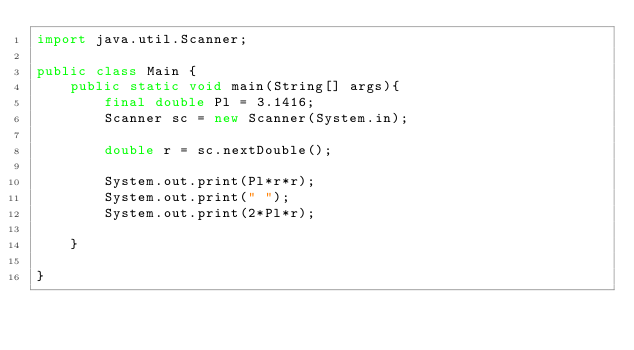Convert code to text. <code><loc_0><loc_0><loc_500><loc_500><_Java_>import java.util.Scanner;

public class Main {
	public static void main(String[] args){
		final double Pl = 3.1416;
		Scanner sc = new Scanner(System.in);

		double r = sc.nextDouble();
		
		System.out.print(Pl*r*r);
		System.out.print(" ");
		System.out.print(2*Pl*r);
		
	}

}
</code> 